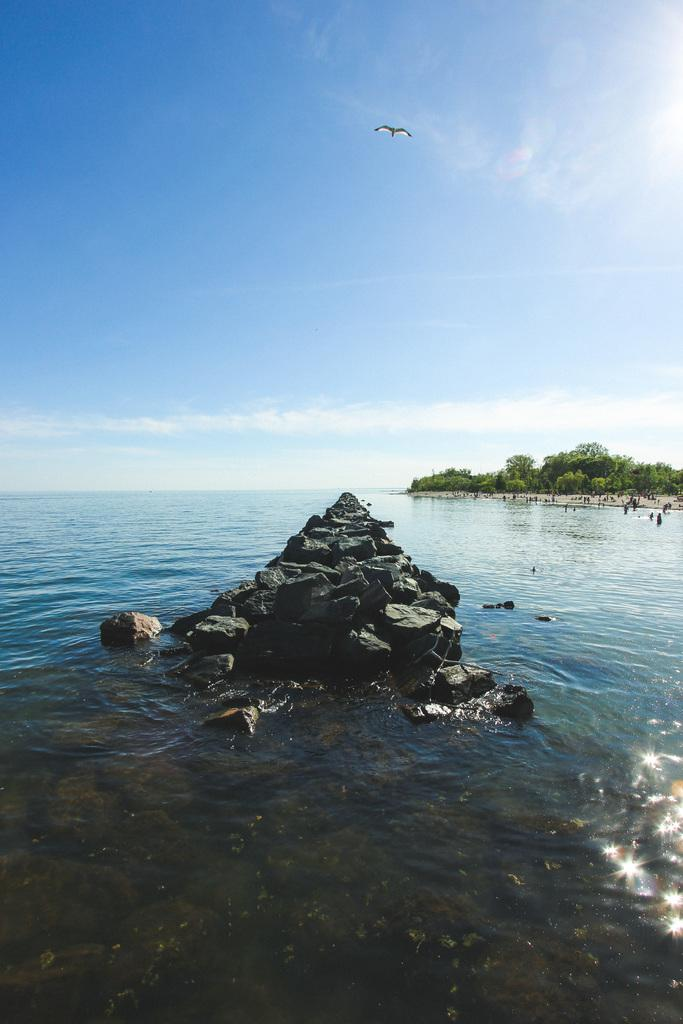What is visible in the image? Water is visible in the image. What can be seen in the background of the image? There are trees, a bird, and clouds in the sky in the background of the image. Where are the dolls being held in the prison in the image? There are no dolls or prison present in the image; it features water, trees, a bird, and clouds. 